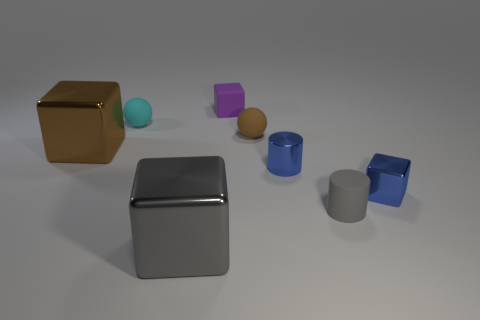Are there more cyan objects than large purple matte things?
Offer a terse response. Yes. How many shiny objects are tiny gray spheres or gray cylinders?
Ensure brevity in your answer.  0. How many metal things are the same color as the metallic cylinder?
Offer a terse response. 1. What is the material of the purple thing to the left of the gray thing that is behind the gray metallic object that is in front of the purple object?
Keep it short and to the point. Rubber. There is a small rubber object in front of the metallic block on the left side of the cyan object; what color is it?
Your response must be concise. Gray. How many big objects are either matte cylinders or metallic objects?
Your response must be concise. 2. How many tiny brown objects are the same material as the brown ball?
Your answer should be very brief. 0. How big is the metal block behind the small shiny cylinder?
Offer a terse response. Large. What is the shape of the small thing that is on the left side of the tiny cube that is behind the cyan rubber object?
Keep it short and to the point. Sphere. How many big cubes are behind the tiny blue object on the left side of the small thing that is on the right side of the small gray matte object?
Offer a terse response. 1. 